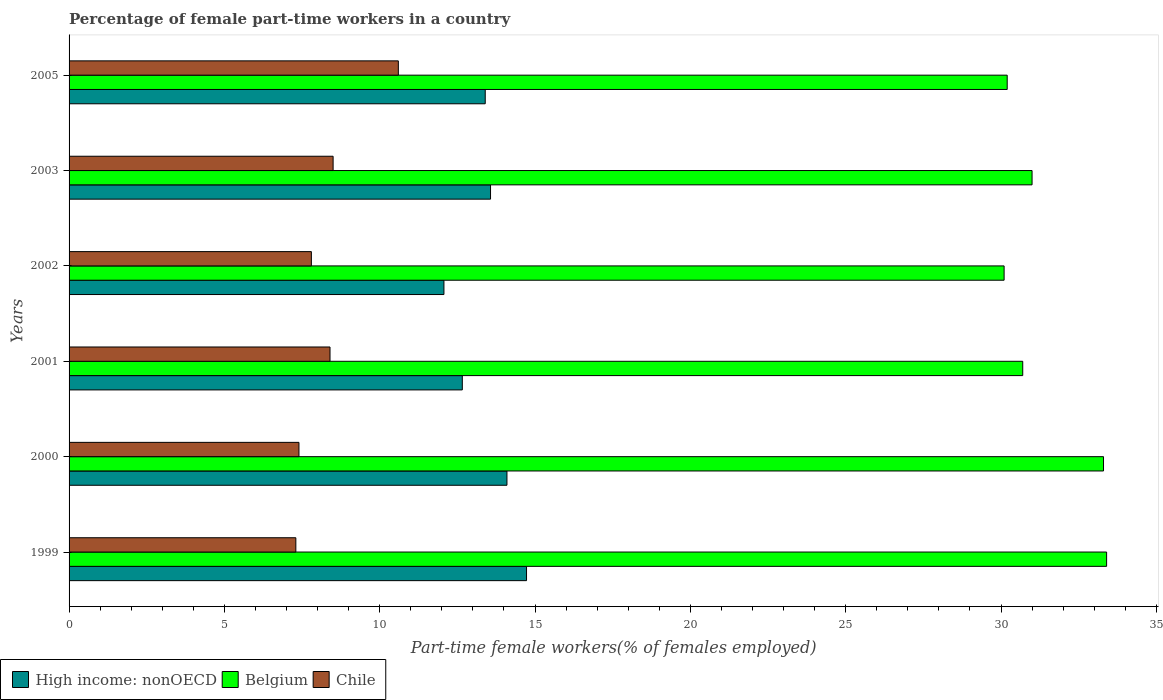How many different coloured bars are there?
Give a very brief answer. 3. How many groups of bars are there?
Offer a terse response. 6. Are the number of bars per tick equal to the number of legend labels?
Offer a very short reply. Yes. How many bars are there on the 6th tick from the top?
Give a very brief answer. 3. In how many cases, is the number of bars for a given year not equal to the number of legend labels?
Offer a very short reply. 0. What is the percentage of female part-time workers in Chile in 2001?
Provide a succinct answer. 8.4. Across all years, what is the maximum percentage of female part-time workers in High income: nonOECD?
Provide a succinct answer. 14.73. Across all years, what is the minimum percentage of female part-time workers in Belgium?
Your response must be concise. 30.1. In which year was the percentage of female part-time workers in High income: nonOECD maximum?
Make the answer very short. 1999. What is the total percentage of female part-time workers in Belgium in the graph?
Give a very brief answer. 188.7. What is the difference between the percentage of female part-time workers in High income: nonOECD in 2001 and that in 2003?
Your answer should be compact. -0.91. What is the difference between the percentage of female part-time workers in High income: nonOECD in 2001 and the percentage of female part-time workers in Belgium in 2002?
Give a very brief answer. -17.44. What is the average percentage of female part-time workers in High income: nonOECD per year?
Provide a short and direct response. 13.42. In the year 1999, what is the difference between the percentage of female part-time workers in Belgium and percentage of female part-time workers in High income: nonOECD?
Make the answer very short. 18.67. What is the ratio of the percentage of female part-time workers in Belgium in 1999 to that in 2002?
Keep it short and to the point. 1.11. Is the percentage of female part-time workers in Belgium in 2001 less than that in 2003?
Make the answer very short. Yes. Is the difference between the percentage of female part-time workers in Belgium in 2002 and 2003 greater than the difference between the percentage of female part-time workers in High income: nonOECD in 2002 and 2003?
Keep it short and to the point. Yes. What is the difference between the highest and the second highest percentage of female part-time workers in High income: nonOECD?
Your response must be concise. 0.63. What is the difference between the highest and the lowest percentage of female part-time workers in Chile?
Your answer should be compact. 3.3. In how many years, is the percentage of female part-time workers in Belgium greater than the average percentage of female part-time workers in Belgium taken over all years?
Your answer should be compact. 2. Is the sum of the percentage of female part-time workers in Chile in 2002 and 2005 greater than the maximum percentage of female part-time workers in Belgium across all years?
Offer a terse response. No. What does the 3rd bar from the bottom in 2000 represents?
Ensure brevity in your answer.  Chile. How many years are there in the graph?
Make the answer very short. 6. What is the difference between two consecutive major ticks on the X-axis?
Keep it short and to the point. 5. Does the graph contain grids?
Ensure brevity in your answer.  No. How many legend labels are there?
Ensure brevity in your answer.  3. How are the legend labels stacked?
Keep it short and to the point. Horizontal. What is the title of the graph?
Offer a terse response. Percentage of female part-time workers in a country. What is the label or title of the X-axis?
Provide a succinct answer. Part-time female workers(% of females employed). What is the Part-time female workers(% of females employed) in High income: nonOECD in 1999?
Your answer should be compact. 14.73. What is the Part-time female workers(% of females employed) in Belgium in 1999?
Keep it short and to the point. 33.4. What is the Part-time female workers(% of females employed) in Chile in 1999?
Offer a terse response. 7.3. What is the Part-time female workers(% of females employed) in High income: nonOECD in 2000?
Provide a short and direct response. 14.1. What is the Part-time female workers(% of females employed) in Belgium in 2000?
Your answer should be very brief. 33.3. What is the Part-time female workers(% of females employed) in Chile in 2000?
Provide a succinct answer. 7.4. What is the Part-time female workers(% of females employed) in High income: nonOECD in 2001?
Make the answer very short. 12.66. What is the Part-time female workers(% of females employed) of Belgium in 2001?
Your answer should be very brief. 30.7. What is the Part-time female workers(% of females employed) in Chile in 2001?
Your response must be concise. 8.4. What is the Part-time female workers(% of females employed) in High income: nonOECD in 2002?
Your response must be concise. 12.07. What is the Part-time female workers(% of females employed) in Belgium in 2002?
Provide a short and direct response. 30.1. What is the Part-time female workers(% of females employed) in Chile in 2002?
Ensure brevity in your answer.  7.8. What is the Part-time female workers(% of females employed) of High income: nonOECD in 2003?
Offer a terse response. 13.57. What is the Part-time female workers(% of females employed) in Belgium in 2003?
Offer a terse response. 31. What is the Part-time female workers(% of females employed) of Chile in 2003?
Your answer should be very brief. 8.5. What is the Part-time female workers(% of females employed) in High income: nonOECD in 2005?
Your response must be concise. 13.4. What is the Part-time female workers(% of females employed) of Belgium in 2005?
Provide a short and direct response. 30.2. What is the Part-time female workers(% of females employed) in Chile in 2005?
Provide a succinct answer. 10.6. Across all years, what is the maximum Part-time female workers(% of females employed) of High income: nonOECD?
Your answer should be very brief. 14.73. Across all years, what is the maximum Part-time female workers(% of females employed) of Belgium?
Provide a short and direct response. 33.4. Across all years, what is the maximum Part-time female workers(% of females employed) in Chile?
Make the answer very short. 10.6. Across all years, what is the minimum Part-time female workers(% of females employed) of High income: nonOECD?
Give a very brief answer. 12.07. Across all years, what is the minimum Part-time female workers(% of females employed) of Belgium?
Offer a very short reply. 30.1. Across all years, what is the minimum Part-time female workers(% of females employed) in Chile?
Ensure brevity in your answer.  7.3. What is the total Part-time female workers(% of females employed) in High income: nonOECD in the graph?
Keep it short and to the point. 80.51. What is the total Part-time female workers(% of females employed) in Belgium in the graph?
Make the answer very short. 188.7. What is the total Part-time female workers(% of females employed) in Chile in the graph?
Your response must be concise. 50. What is the difference between the Part-time female workers(% of females employed) in High income: nonOECD in 1999 and that in 2000?
Offer a very short reply. 0.63. What is the difference between the Part-time female workers(% of females employed) of Belgium in 1999 and that in 2000?
Make the answer very short. 0.1. What is the difference between the Part-time female workers(% of females employed) of High income: nonOECD in 1999 and that in 2001?
Make the answer very short. 2.07. What is the difference between the Part-time female workers(% of females employed) of High income: nonOECD in 1999 and that in 2002?
Keep it short and to the point. 2.66. What is the difference between the Part-time female workers(% of females employed) in Belgium in 1999 and that in 2002?
Provide a succinct answer. 3.3. What is the difference between the Part-time female workers(% of females employed) in Chile in 1999 and that in 2002?
Offer a terse response. -0.5. What is the difference between the Part-time female workers(% of females employed) of High income: nonOECD in 1999 and that in 2003?
Provide a short and direct response. 1.16. What is the difference between the Part-time female workers(% of females employed) in Belgium in 1999 and that in 2003?
Make the answer very short. 2.4. What is the difference between the Part-time female workers(% of females employed) in High income: nonOECD in 1999 and that in 2005?
Your answer should be very brief. 1.33. What is the difference between the Part-time female workers(% of females employed) in Chile in 1999 and that in 2005?
Offer a terse response. -3.3. What is the difference between the Part-time female workers(% of females employed) of High income: nonOECD in 2000 and that in 2001?
Make the answer very short. 1.44. What is the difference between the Part-time female workers(% of females employed) of Belgium in 2000 and that in 2001?
Ensure brevity in your answer.  2.6. What is the difference between the Part-time female workers(% of females employed) of High income: nonOECD in 2000 and that in 2002?
Your response must be concise. 2.03. What is the difference between the Part-time female workers(% of females employed) in Belgium in 2000 and that in 2002?
Provide a short and direct response. 3.2. What is the difference between the Part-time female workers(% of females employed) in High income: nonOECD in 2000 and that in 2003?
Give a very brief answer. 0.53. What is the difference between the Part-time female workers(% of females employed) in Chile in 2000 and that in 2003?
Ensure brevity in your answer.  -1.1. What is the difference between the Part-time female workers(% of females employed) in High income: nonOECD in 2000 and that in 2005?
Provide a short and direct response. 0.7. What is the difference between the Part-time female workers(% of females employed) of Chile in 2000 and that in 2005?
Your answer should be very brief. -3.2. What is the difference between the Part-time female workers(% of females employed) of High income: nonOECD in 2001 and that in 2002?
Give a very brief answer. 0.59. What is the difference between the Part-time female workers(% of females employed) in Belgium in 2001 and that in 2002?
Provide a succinct answer. 0.6. What is the difference between the Part-time female workers(% of females employed) in High income: nonOECD in 2001 and that in 2003?
Provide a short and direct response. -0.91. What is the difference between the Part-time female workers(% of females employed) in Belgium in 2001 and that in 2003?
Your response must be concise. -0.3. What is the difference between the Part-time female workers(% of females employed) in High income: nonOECD in 2001 and that in 2005?
Ensure brevity in your answer.  -0.74. What is the difference between the Part-time female workers(% of females employed) of Belgium in 2001 and that in 2005?
Provide a short and direct response. 0.5. What is the difference between the Part-time female workers(% of females employed) in High income: nonOECD in 2002 and that in 2003?
Give a very brief answer. -1.5. What is the difference between the Part-time female workers(% of females employed) in Chile in 2002 and that in 2003?
Offer a terse response. -0.7. What is the difference between the Part-time female workers(% of females employed) of High income: nonOECD in 2002 and that in 2005?
Give a very brief answer. -1.33. What is the difference between the Part-time female workers(% of females employed) in Belgium in 2002 and that in 2005?
Your answer should be very brief. -0.1. What is the difference between the Part-time female workers(% of females employed) in High income: nonOECD in 2003 and that in 2005?
Provide a succinct answer. 0.17. What is the difference between the Part-time female workers(% of females employed) of Belgium in 2003 and that in 2005?
Ensure brevity in your answer.  0.8. What is the difference between the Part-time female workers(% of females employed) in High income: nonOECD in 1999 and the Part-time female workers(% of females employed) in Belgium in 2000?
Provide a short and direct response. -18.57. What is the difference between the Part-time female workers(% of females employed) in High income: nonOECD in 1999 and the Part-time female workers(% of females employed) in Chile in 2000?
Your answer should be very brief. 7.33. What is the difference between the Part-time female workers(% of females employed) of Belgium in 1999 and the Part-time female workers(% of females employed) of Chile in 2000?
Ensure brevity in your answer.  26. What is the difference between the Part-time female workers(% of females employed) of High income: nonOECD in 1999 and the Part-time female workers(% of females employed) of Belgium in 2001?
Provide a short and direct response. -15.97. What is the difference between the Part-time female workers(% of females employed) of High income: nonOECD in 1999 and the Part-time female workers(% of females employed) of Chile in 2001?
Give a very brief answer. 6.33. What is the difference between the Part-time female workers(% of females employed) of Belgium in 1999 and the Part-time female workers(% of females employed) of Chile in 2001?
Keep it short and to the point. 25. What is the difference between the Part-time female workers(% of females employed) in High income: nonOECD in 1999 and the Part-time female workers(% of females employed) in Belgium in 2002?
Give a very brief answer. -15.37. What is the difference between the Part-time female workers(% of females employed) in High income: nonOECD in 1999 and the Part-time female workers(% of females employed) in Chile in 2002?
Provide a short and direct response. 6.93. What is the difference between the Part-time female workers(% of females employed) in Belgium in 1999 and the Part-time female workers(% of females employed) in Chile in 2002?
Provide a succinct answer. 25.6. What is the difference between the Part-time female workers(% of females employed) of High income: nonOECD in 1999 and the Part-time female workers(% of females employed) of Belgium in 2003?
Your answer should be very brief. -16.27. What is the difference between the Part-time female workers(% of females employed) in High income: nonOECD in 1999 and the Part-time female workers(% of females employed) in Chile in 2003?
Make the answer very short. 6.23. What is the difference between the Part-time female workers(% of females employed) of Belgium in 1999 and the Part-time female workers(% of females employed) of Chile in 2003?
Keep it short and to the point. 24.9. What is the difference between the Part-time female workers(% of females employed) in High income: nonOECD in 1999 and the Part-time female workers(% of females employed) in Belgium in 2005?
Offer a terse response. -15.47. What is the difference between the Part-time female workers(% of females employed) in High income: nonOECD in 1999 and the Part-time female workers(% of females employed) in Chile in 2005?
Make the answer very short. 4.13. What is the difference between the Part-time female workers(% of females employed) of Belgium in 1999 and the Part-time female workers(% of females employed) of Chile in 2005?
Provide a short and direct response. 22.8. What is the difference between the Part-time female workers(% of females employed) in High income: nonOECD in 2000 and the Part-time female workers(% of females employed) in Belgium in 2001?
Your answer should be very brief. -16.6. What is the difference between the Part-time female workers(% of females employed) in High income: nonOECD in 2000 and the Part-time female workers(% of females employed) in Chile in 2001?
Your response must be concise. 5.7. What is the difference between the Part-time female workers(% of females employed) of Belgium in 2000 and the Part-time female workers(% of females employed) of Chile in 2001?
Make the answer very short. 24.9. What is the difference between the Part-time female workers(% of females employed) in High income: nonOECD in 2000 and the Part-time female workers(% of females employed) in Belgium in 2002?
Provide a succinct answer. -16. What is the difference between the Part-time female workers(% of females employed) of High income: nonOECD in 2000 and the Part-time female workers(% of females employed) of Chile in 2002?
Ensure brevity in your answer.  6.3. What is the difference between the Part-time female workers(% of females employed) of High income: nonOECD in 2000 and the Part-time female workers(% of females employed) of Belgium in 2003?
Provide a succinct answer. -16.9. What is the difference between the Part-time female workers(% of females employed) of High income: nonOECD in 2000 and the Part-time female workers(% of females employed) of Chile in 2003?
Ensure brevity in your answer.  5.6. What is the difference between the Part-time female workers(% of females employed) in Belgium in 2000 and the Part-time female workers(% of females employed) in Chile in 2003?
Keep it short and to the point. 24.8. What is the difference between the Part-time female workers(% of females employed) of High income: nonOECD in 2000 and the Part-time female workers(% of females employed) of Belgium in 2005?
Keep it short and to the point. -16.1. What is the difference between the Part-time female workers(% of females employed) in High income: nonOECD in 2000 and the Part-time female workers(% of females employed) in Chile in 2005?
Provide a short and direct response. 3.5. What is the difference between the Part-time female workers(% of females employed) in Belgium in 2000 and the Part-time female workers(% of females employed) in Chile in 2005?
Provide a short and direct response. 22.7. What is the difference between the Part-time female workers(% of females employed) of High income: nonOECD in 2001 and the Part-time female workers(% of females employed) of Belgium in 2002?
Your answer should be compact. -17.44. What is the difference between the Part-time female workers(% of females employed) in High income: nonOECD in 2001 and the Part-time female workers(% of females employed) in Chile in 2002?
Provide a succinct answer. 4.86. What is the difference between the Part-time female workers(% of females employed) in Belgium in 2001 and the Part-time female workers(% of females employed) in Chile in 2002?
Keep it short and to the point. 22.9. What is the difference between the Part-time female workers(% of females employed) of High income: nonOECD in 2001 and the Part-time female workers(% of females employed) of Belgium in 2003?
Your answer should be very brief. -18.34. What is the difference between the Part-time female workers(% of females employed) in High income: nonOECD in 2001 and the Part-time female workers(% of females employed) in Chile in 2003?
Offer a terse response. 4.16. What is the difference between the Part-time female workers(% of females employed) in High income: nonOECD in 2001 and the Part-time female workers(% of females employed) in Belgium in 2005?
Your response must be concise. -17.54. What is the difference between the Part-time female workers(% of females employed) in High income: nonOECD in 2001 and the Part-time female workers(% of females employed) in Chile in 2005?
Ensure brevity in your answer.  2.06. What is the difference between the Part-time female workers(% of females employed) in Belgium in 2001 and the Part-time female workers(% of females employed) in Chile in 2005?
Your response must be concise. 20.1. What is the difference between the Part-time female workers(% of females employed) in High income: nonOECD in 2002 and the Part-time female workers(% of females employed) in Belgium in 2003?
Keep it short and to the point. -18.93. What is the difference between the Part-time female workers(% of females employed) of High income: nonOECD in 2002 and the Part-time female workers(% of females employed) of Chile in 2003?
Make the answer very short. 3.57. What is the difference between the Part-time female workers(% of females employed) of Belgium in 2002 and the Part-time female workers(% of females employed) of Chile in 2003?
Your response must be concise. 21.6. What is the difference between the Part-time female workers(% of females employed) in High income: nonOECD in 2002 and the Part-time female workers(% of females employed) in Belgium in 2005?
Keep it short and to the point. -18.13. What is the difference between the Part-time female workers(% of females employed) of High income: nonOECD in 2002 and the Part-time female workers(% of females employed) of Chile in 2005?
Offer a terse response. 1.47. What is the difference between the Part-time female workers(% of females employed) in High income: nonOECD in 2003 and the Part-time female workers(% of females employed) in Belgium in 2005?
Offer a very short reply. -16.63. What is the difference between the Part-time female workers(% of females employed) in High income: nonOECD in 2003 and the Part-time female workers(% of females employed) in Chile in 2005?
Keep it short and to the point. 2.97. What is the difference between the Part-time female workers(% of females employed) of Belgium in 2003 and the Part-time female workers(% of females employed) of Chile in 2005?
Provide a succinct answer. 20.4. What is the average Part-time female workers(% of females employed) in High income: nonOECD per year?
Offer a terse response. 13.42. What is the average Part-time female workers(% of females employed) in Belgium per year?
Ensure brevity in your answer.  31.45. What is the average Part-time female workers(% of females employed) in Chile per year?
Provide a succinct answer. 8.33. In the year 1999, what is the difference between the Part-time female workers(% of females employed) in High income: nonOECD and Part-time female workers(% of females employed) in Belgium?
Your answer should be very brief. -18.67. In the year 1999, what is the difference between the Part-time female workers(% of females employed) in High income: nonOECD and Part-time female workers(% of females employed) in Chile?
Offer a terse response. 7.43. In the year 1999, what is the difference between the Part-time female workers(% of females employed) in Belgium and Part-time female workers(% of females employed) in Chile?
Give a very brief answer. 26.1. In the year 2000, what is the difference between the Part-time female workers(% of females employed) of High income: nonOECD and Part-time female workers(% of females employed) of Belgium?
Make the answer very short. -19.2. In the year 2000, what is the difference between the Part-time female workers(% of females employed) in High income: nonOECD and Part-time female workers(% of females employed) in Chile?
Make the answer very short. 6.7. In the year 2000, what is the difference between the Part-time female workers(% of females employed) in Belgium and Part-time female workers(% of females employed) in Chile?
Offer a very short reply. 25.9. In the year 2001, what is the difference between the Part-time female workers(% of females employed) of High income: nonOECD and Part-time female workers(% of females employed) of Belgium?
Keep it short and to the point. -18.04. In the year 2001, what is the difference between the Part-time female workers(% of females employed) in High income: nonOECD and Part-time female workers(% of females employed) in Chile?
Keep it short and to the point. 4.26. In the year 2001, what is the difference between the Part-time female workers(% of females employed) of Belgium and Part-time female workers(% of females employed) of Chile?
Provide a short and direct response. 22.3. In the year 2002, what is the difference between the Part-time female workers(% of females employed) of High income: nonOECD and Part-time female workers(% of females employed) of Belgium?
Your response must be concise. -18.03. In the year 2002, what is the difference between the Part-time female workers(% of females employed) in High income: nonOECD and Part-time female workers(% of females employed) in Chile?
Provide a short and direct response. 4.27. In the year 2002, what is the difference between the Part-time female workers(% of females employed) in Belgium and Part-time female workers(% of females employed) in Chile?
Offer a very short reply. 22.3. In the year 2003, what is the difference between the Part-time female workers(% of females employed) in High income: nonOECD and Part-time female workers(% of females employed) in Belgium?
Offer a very short reply. -17.43. In the year 2003, what is the difference between the Part-time female workers(% of females employed) of High income: nonOECD and Part-time female workers(% of females employed) of Chile?
Ensure brevity in your answer.  5.07. In the year 2003, what is the difference between the Part-time female workers(% of females employed) in Belgium and Part-time female workers(% of females employed) in Chile?
Provide a succinct answer. 22.5. In the year 2005, what is the difference between the Part-time female workers(% of females employed) in High income: nonOECD and Part-time female workers(% of females employed) in Belgium?
Provide a short and direct response. -16.8. In the year 2005, what is the difference between the Part-time female workers(% of females employed) in High income: nonOECD and Part-time female workers(% of females employed) in Chile?
Ensure brevity in your answer.  2.8. In the year 2005, what is the difference between the Part-time female workers(% of females employed) in Belgium and Part-time female workers(% of females employed) in Chile?
Offer a terse response. 19.6. What is the ratio of the Part-time female workers(% of females employed) of High income: nonOECD in 1999 to that in 2000?
Ensure brevity in your answer.  1.04. What is the ratio of the Part-time female workers(% of females employed) in Belgium in 1999 to that in 2000?
Provide a succinct answer. 1. What is the ratio of the Part-time female workers(% of females employed) in Chile in 1999 to that in 2000?
Give a very brief answer. 0.99. What is the ratio of the Part-time female workers(% of females employed) of High income: nonOECD in 1999 to that in 2001?
Provide a short and direct response. 1.16. What is the ratio of the Part-time female workers(% of females employed) in Belgium in 1999 to that in 2001?
Offer a terse response. 1.09. What is the ratio of the Part-time female workers(% of females employed) in Chile in 1999 to that in 2001?
Provide a succinct answer. 0.87. What is the ratio of the Part-time female workers(% of females employed) of High income: nonOECD in 1999 to that in 2002?
Give a very brief answer. 1.22. What is the ratio of the Part-time female workers(% of females employed) in Belgium in 1999 to that in 2002?
Your response must be concise. 1.11. What is the ratio of the Part-time female workers(% of females employed) in Chile in 1999 to that in 2002?
Give a very brief answer. 0.94. What is the ratio of the Part-time female workers(% of females employed) in High income: nonOECD in 1999 to that in 2003?
Your answer should be very brief. 1.09. What is the ratio of the Part-time female workers(% of females employed) in Belgium in 1999 to that in 2003?
Ensure brevity in your answer.  1.08. What is the ratio of the Part-time female workers(% of females employed) of Chile in 1999 to that in 2003?
Make the answer very short. 0.86. What is the ratio of the Part-time female workers(% of females employed) of High income: nonOECD in 1999 to that in 2005?
Provide a short and direct response. 1.1. What is the ratio of the Part-time female workers(% of females employed) of Belgium in 1999 to that in 2005?
Make the answer very short. 1.11. What is the ratio of the Part-time female workers(% of females employed) of Chile in 1999 to that in 2005?
Make the answer very short. 0.69. What is the ratio of the Part-time female workers(% of females employed) of High income: nonOECD in 2000 to that in 2001?
Offer a very short reply. 1.11. What is the ratio of the Part-time female workers(% of females employed) of Belgium in 2000 to that in 2001?
Your answer should be compact. 1.08. What is the ratio of the Part-time female workers(% of females employed) in Chile in 2000 to that in 2001?
Your response must be concise. 0.88. What is the ratio of the Part-time female workers(% of females employed) in High income: nonOECD in 2000 to that in 2002?
Your answer should be compact. 1.17. What is the ratio of the Part-time female workers(% of females employed) of Belgium in 2000 to that in 2002?
Keep it short and to the point. 1.11. What is the ratio of the Part-time female workers(% of females employed) in Chile in 2000 to that in 2002?
Offer a very short reply. 0.95. What is the ratio of the Part-time female workers(% of females employed) in High income: nonOECD in 2000 to that in 2003?
Make the answer very short. 1.04. What is the ratio of the Part-time female workers(% of females employed) of Belgium in 2000 to that in 2003?
Your answer should be very brief. 1.07. What is the ratio of the Part-time female workers(% of females employed) in Chile in 2000 to that in 2003?
Offer a terse response. 0.87. What is the ratio of the Part-time female workers(% of females employed) of High income: nonOECD in 2000 to that in 2005?
Give a very brief answer. 1.05. What is the ratio of the Part-time female workers(% of females employed) in Belgium in 2000 to that in 2005?
Give a very brief answer. 1.1. What is the ratio of the Part-time female workers(% of females employed) in Chile in 2000 to that in 2005?
Ensure brevity in your answer.  0.7. What is the ratio of the Part-time female workers(% of females employed) of High income: nonOECD in 2001 to that in 2002?
Offer a terse response. 1.05. What is the ratio of the Part-time female workers(% of females employed) of Belgium in 2001 to that in 2002?
Keep it short and to the point. 1.02. What is the ratio of the Part-time female workers(% of females employed) of High income: nonOECD in 2001 to that in 2003?
Make the answer very short. 0.93. What is the ratio of the Part-time female workers(% of females employed) in Belgium in 2001 to that in 2003?
Make the answer very short. 0.99. What is the ratio of the Part-time female workers(% of females employed) in High income: nonOECD in 2001 to that in 2005?
Your response must be concise. 0.94. What is the ratio of the Part-time female workers(% of females employed) of Belgium in 2001 to that in 2005?
Make the answer very short. 1.02. What is the ratio of the Part-time female workers(% of females employed) in Chile in 2001 to that in 2005?
Provide a short and direct response. 0.79. What is the ratio of the Part-time female workers(% of females employed) in High income: nonOECD in 2002 to that in 2003?
Keep it short and to the point. 0.89. What is the ratio of the Part-time female workers(% of females employed) in Belgium in 2002 to that in 2003?
Your answer should be very brief. 0.97. What is the ratio of the Part-time female workers(% of females employed) of Chile in 2002 to that in 2003?
Make the answer very short. 0.92. What is the ratio of the Part-time female workers(% of females employed) in High income: nonOECD in 2002 to that in 2005?
Your answer should be very brief. 0.9. What is the ratio of the Part-time female workers(% of females employed) in Belgium in 2002 to that in 2005?
Make the answer very short. 1. What is the ratio of the Part-time female workers(% of females employed) of Chile in 2002 to that in 2005?
Make the answer very short. 0.74. What is the ratio of the Part-time female workers(% of females employed) of High income: nonOECD in 2003 to that in 2005?
Provide a succinct answer. 1.01. What is the ratio of the Part-time female workers(% of females employed) in Belgium in 2003 to that in 2005?
Provide a succinct answer. 1.03. What is the ratio of the Part-time female workers(% of females employed) in Chile in 2003 to that in 2005?
Give a very brief answer. 0.8. What is the difference between the highest and the second highest Part-time female workers(% of females employed) in High income: nonOECD?
Ensure brevity in your answer.  0.63. What is the difference between the highest and the lowest Part-time female workers(% of females employed) in High income: nonOECD?
Provide a succinct answer. 2.66. What is the difference between the highest and the lowest Part-time female workers(% of females employed) of Belgium?
Your answer should be compact. 3.3. 